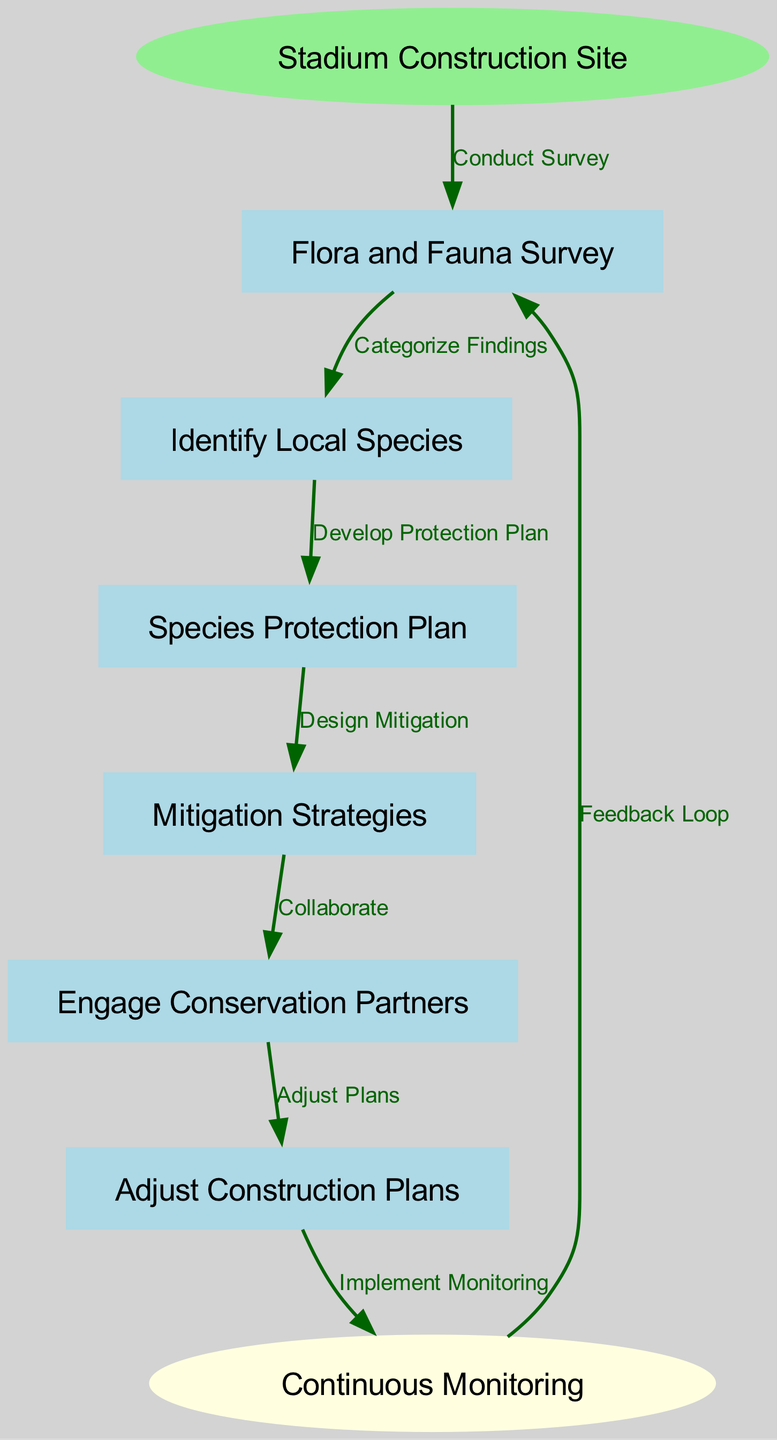What is the starting point of the process? The diagram shows "Stadium Construction Site" as the starting node, indicating where the entire process begins.
Answer: Stadium Construction Site How many nodes are in the diagram? By counting all the distinct nodes illustrated in the diagram, we find there are eight nodes connected in a sequence, including the start and end points.
Answer: 8 What is the relationship between "Flora and Fauna Survey" and "Identify Local Species"? The edge labeled "Categorize Findings" connects these two nodes, showing that the survey leads to species identification.
Answer: Categorize Findings What follows after "Species Protection Plan"? The next node in the sequence after "Species Protection Plan" is "Mitigation Strategies," as indicated by the directed edge.
Answer: Mitigation Strategies Which node represents the continuous oversight of local species? The "Continuous Monitoring" node represents the ongoing efforts to track the health of local flora and fauna during the construction process.
Answer: Continuous Monitoring What action is taken after identifying local species? After identifying local species, the action taken is to "Develop Protection Plan," based on the categorized findings from the flora and fauna survey.
Answer: Develop Protection Plan How many edges connect the "Mitigation Strategies" node? There is one outgoing edge from "Mitigation Strategies," indicating that it leads to engaging with conservation partners.
Answer: 1 What is the final step in the process depicted in the diagram? The final step in the process is represented by the "Continuous Monitoring" node, which completes the cycle of feedback to the Flora and Fauna Survey.
Answer: Continuous Monitoring What is the purpose of "Engage Conservation Partners"? The "Engage Conservation Partners" node aims to create collaborations that will inform necessary adjustments in construction plans to protect local biodiversity.
Answer: Collaborate 